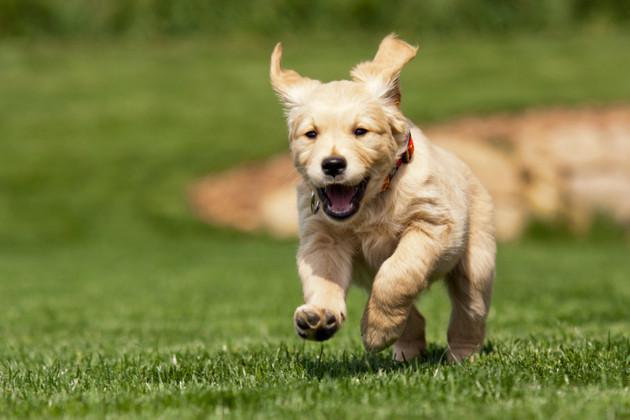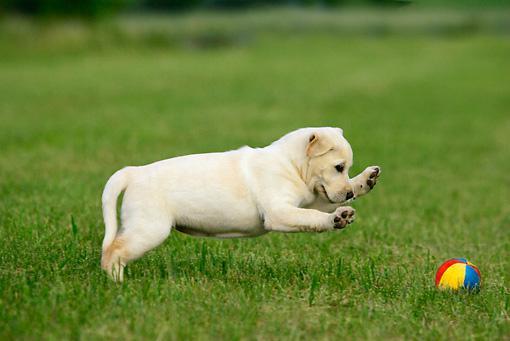The first image is the image on the left, the second image is the image on the right. Given the left and right images, does the statement "Each image shows a puppy posed with a sports ball, and the puppy on the right is sitting behind a soccer ball with one paw atop it." hold true? Answer yes or no. No. The first image is the image on the left, the second image is the image on the right. Assess this claim about the two images: "The dog in the image on the right has one paw resting on a ball.". Correct or not? Answer yes or no. No. 